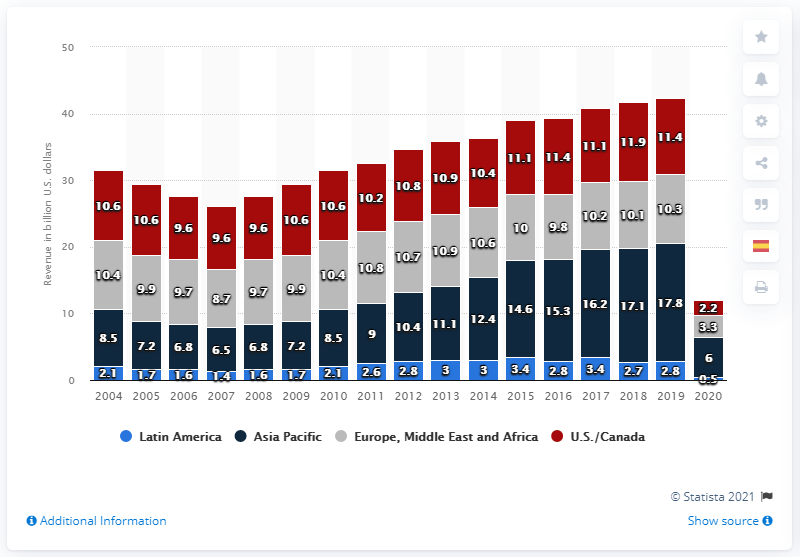Mention a couple of crucial points in this snapshot. In 2020, the global box office revenue was approximately $11.9 billion. 